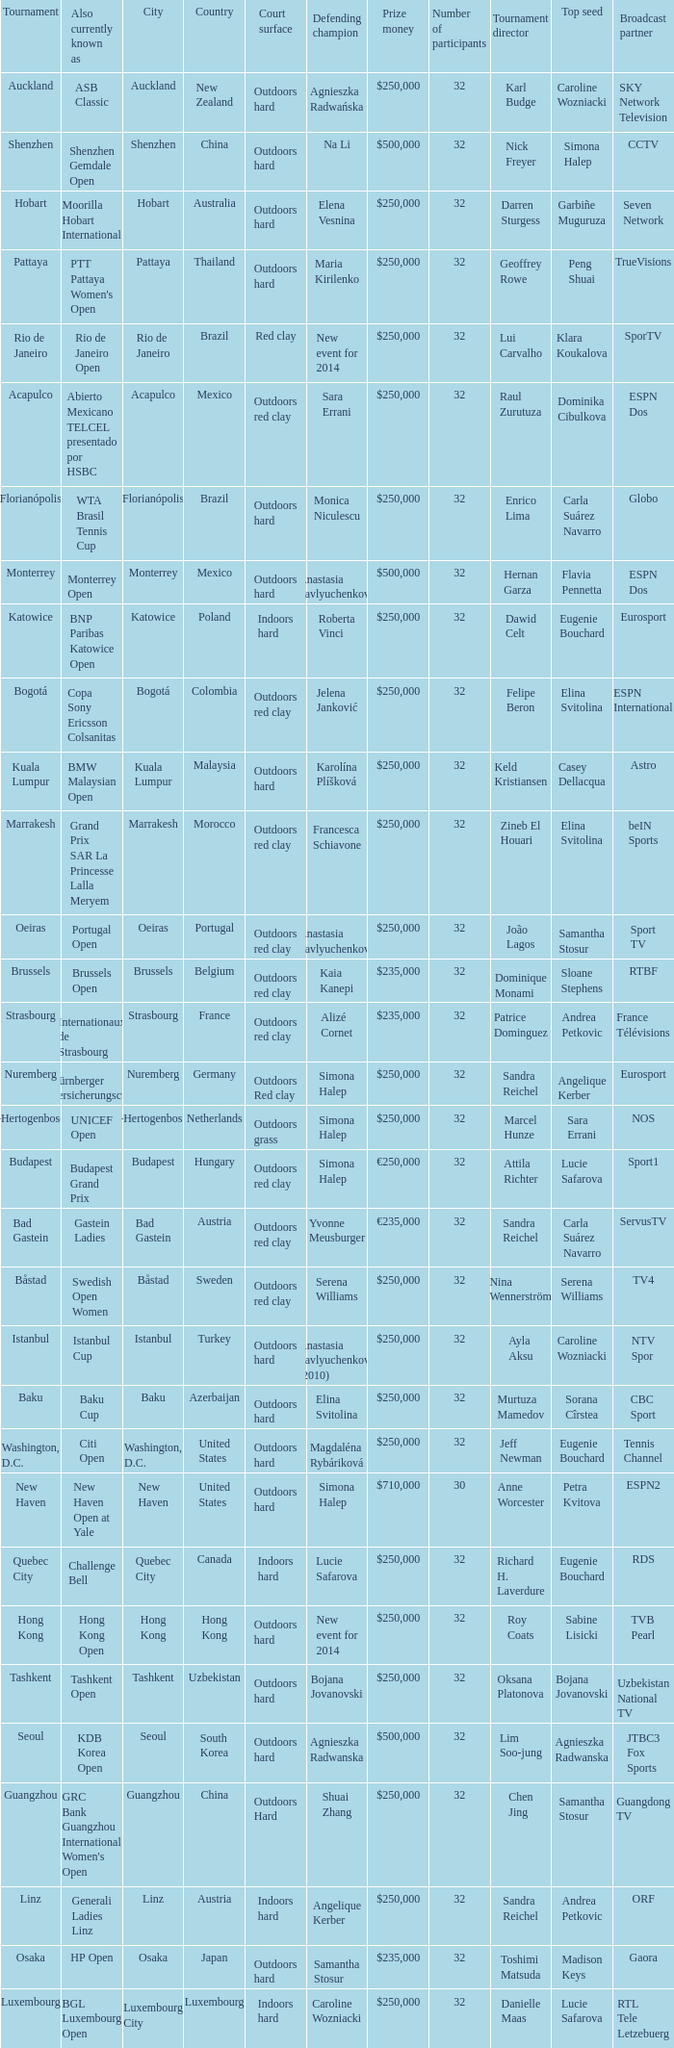Help me parse the entirety of this table. {'header': ['Tournament', 'Also currently known as', 'City', 'Country', 'Court surface', 'Defending champion', 'Prize money', 'Number of participants', 'Tournament director', 'Top seed', 'Broadcast partner'], 'rows': [['Auckland', 'ASB Classic', 'Auckland', 'New Zealand', 'Outdoors hard', 'Agnieszka Radwańska', '$250,000', '32', 'Karl Budge', 'Caroline Wozniacki', 'SKY Network Television'], ['Shenzhen', 'Shenzhen Gemdale Open', 'Shenzhen', 'China', 'Outdoors hard', 'Na Li', '$500,000', '32', 'Nick Freyer', 'Simona Halep', 'CCTV'], ['Hobart', 'Moorilla Hobart International', 'Hobart', 'Australia', 'Outdoors hard', 'Elena Vesnina', '$250,000', '32', 'Darren Sturgess', 'Garbiñe Muguruza', 'Seven Network'], ['Pattaya', "PTT Pattaya Women's Open", 'Pattaya', 'Thailand', 'Outdoors hard', 'Maria Kirilenko', '$250,000', '32', 'Geoffrey Rowe', 'Peng Shuai', 'TrueVisions'], ['Rio de Janeiro', 'Rio de Janeiro Open', 'Rio de Janeiro', 'Brazil', 'Red clay', 'New event for 2014', '$250,000', '32', 'Lui Carvalho', 'Klara Koukalova', 'SporTV'], ['Acapulco', 'Abierto Mexicano TELCEL presentado por HSBC', 'Acapulco', 'Mexico', 'Outdoors red clay', 'Sara Errani', '$250,000', '32', 'Raul Zurutuza', 'Dominika Cibulkova', 'ESPN Dos'], ['Florianópolis', 'WTA Brasil Tennis Cup', 'Florianópolis', 'Brazil', 'Outdoors hard', 'Monica Niculescu', '$250,000', '32', 'Enrico Lima', 'Carla Suárez Navarro', 'Globo'], ['Monterrey', 'Monterrey Open', 'Monterrey', 'Mexico', 'Outdoors hard', 'Anastasia Pavlyuchenkova', '$500,000', '32', 'Hernan Garza', 'Flavia Pennetta', 'ESPN Dos'], ['Katowice', 'BNP Paribas Katowice Open', 'Katowice', 'Poland', 'Indoors hard', 'Roberta Vinci', '$250,000', '32', 'Dawid Celt', 'Eugenie Bouchard', 'Eurosport'], ['Bogotá', 'Copa Sony Ericsson Colsanitas', 'Bogotá', 'Colombia', 'Outdoors red clay', 'Jelena Janković', '$250,000', '32', 'Felipe Beron', 'Elina Svitolina', 'ESPN International'], ['Kuala Lumpur', 'BMW Malaysian Open', 'Kuala Lumpur', 'Malaysia', 'Outdoors hard', 'Karolína Plíšková', '$250,000', '32', 'Keld Kristiansen', 'Casey Dellacqua', 'Astro'], ['Marrakesh', 'Grand Prix SAR La Princesse Lalla Meryem', 'Marrakesh', 'Morocco', 'Outdoors red clay', 'Francesca Schiavone', '$250,000', '32', 'Zineb El Houari', 'Elina Svitolina', 'beIN Sports'], ['Oeiras', 'Portugal Open', 'Oeiras', 'Portugal', 'Outdoors red clay', 'Anastasia Pavlyuchenkova', '$250,000', '32', 'João Lagos', 'Samantha Stosur', 'Sport TV'], ['Brussels', 'Brussels Open', 'Brussels', 'Belgium', 'Outdoors red clay', 'Kaia Kanepi', '$235,000', '32', 'Dominique Monami', 'Sloane Stephens', 'RTBF'], ['Strasbourg', 'Internationaux de Strasbourg', 'Strasbourg', 'France', 'Outdoors red clay', 'Alizé Cornet', '$235,000', '32', 'Patrice Dominguez', 'Andrea Petkovic', 'France Télévisions'], ['Nuremberg', 'Nürnberger Versicherungscup', 'Nuremberg', 'Germany', 'Outdoors Red clay', 'Simona Halep', '$250,000', '32', 'Sandra Reichel', 'Angelique Kerber', 'Eurosport'], ["'s-Hertogenbosch", 'UNICEF Open', "'s-Hertogenbosch", 'Netherlands', 'Outdoors grass', 'Simona Halep', '$250,000', '32', 'Marcel Hunze', 'Sara Errani', 'NOS'], ['Budapest', 'Budapest Grand Prix', 'Budapest', 'Hungary', 'Outdoors red clay', 'Simona Halep', '€250,000', '32', 'Attila Richter', 'Lucie Safarova', 'Sport1'], ['Bad Gastein', 'Gastein Ladies', 'Bad Gastein', 'Austria', 'Outdoors red clay', 'Yvonne Meusburger', '€235,000', '32', 'Sandra Reichel', 'Carla Suárez Navarro', 'ServusTV'], ['Båstad', 'Swedish Open Women', 'Båstad', 'Sweden', 'Outdoors red clay', 'Serena Williams', '$250,000', '32', 'Nina Wennerström', 'Serena Williams', 'TV4'], ['Istanbul', 'Istanbul Cup', 'Istanbul', 'Turkey', 'Outdoors hard', 'Anastasia Pavlyuchenkova (2010)', '$250,000', '32', 'Ayla Aksu', 'Caroline Wozniacki', 'NTV Spor'], ['Baku', 'Baku Cup', 'Baku', 'Azerbaijan', 'Outdoors hard', 'Elina Svitolina', '$250,000', '32', 'Murtuza Mamedov', 'Sorana Cîrstea', 'CBC Sport'], ['Washington, D.C.', 'Citi Open', 'Washington, D.C.', 'United States', 'Outdoors hard', 'Magdaléna Rybáriková', '$250,000', '32', 'Jeff Newman', 'Eugenie Bouchard', 'Tennis Channel'], ['New Haven', 'New Haven Open at Yale', 'New Haven', 'United States', 'Outdoors hard', 'Simona Halep', '$710,000', '30', 'Anne Worcester', 'Petra Kvitova', 'ESPN2'], ['Quebec City', 'Challenge Bell', 'Quebec City', 'Canada', 'Indoors hard', 'Lucie Safarova', '$250,000', '32', 'Richard H. Laverdure', 'Eugenie Bouchard', 'RDS'], ['Hong Kong', 'Hong Kong Open', 'Hong Kong', 'Hong Kong', 'Outdoors hard', 'New event for 2014', '$250,000', '32', 'Roy Coats', 'Sabine Lisicki', 'TVB Pearl'], ['Tashkent', 'Tashkent Open', 'Tashkent', 'Uzbekistan', 'Outdoors hard', 'Bojana Jovanovski', '$250,000', '32', 'Oksana Platonova', 'Bojana Jovanovski', 'Uzbekistan National TV'], ['Seoul', 'KDB Korea Open', 'Seoul', 'South Korea', 'Outdoors hard', 'Agnieszka Radwanska', '$500,000', '32', 'Lim Soo-jung', 'Agnieszka Radwanska', 'JTBC3 Fox Sports'], ['Guangzhou', "GRC Bank Guangzhou International Women's Open", 'Guangzhou', 'China', 'Outdoors Hard', 'Shuai Zhang', '$250,000', '32', 'Chen Jing', 'Samantha Stosur', 'Guangdong TV'], ['Linz', 'Generali Ladies Linz', 'Linz', 'Austria', 'Indoors hard', 'Angelique Kerber', '$250,000', '32', 'Sandra Reichel', 'Andrea Petkovic', 'ORF'], ['Osaka', 'HP Open', 'Osaka', 'Japan', 'Outdoors hard', 'Samantha Stosur', '$235,000', '32', 'Toshimi Matsuda', 'Madison Keys', 'Gaora'], ['Luxembourg', 'BGL Luxembourg Open', 'Luxembourg City', 'Luxembourg', 'Indoors hard', 'Caroline Wozniacki', '$250,000', '32', 'Danielle Maas', 'Lucie Safarova', 'RTL Tele Letzebuerg']]} What tournament is in katowice? Katowice. 